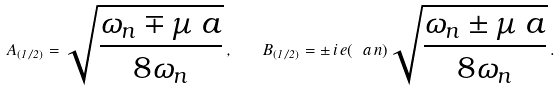Convert formula to latex. <formula><loc_0><loc_0><loc_500><loc_500>A _ { ( 1 / 2 ) } = \sqrt { \frac { \omega _ { n } \mp \mu \ a } { 8 \omega _ { n } } } \, , \quad B _ { ( 1 / 2 ) } = \pm \, i \, e ( \ a \, n ) \sqrt { \frac { \omega _ { n } \pm \mu \ a } { 8 \omega _ { n } } } \, .</formula> 